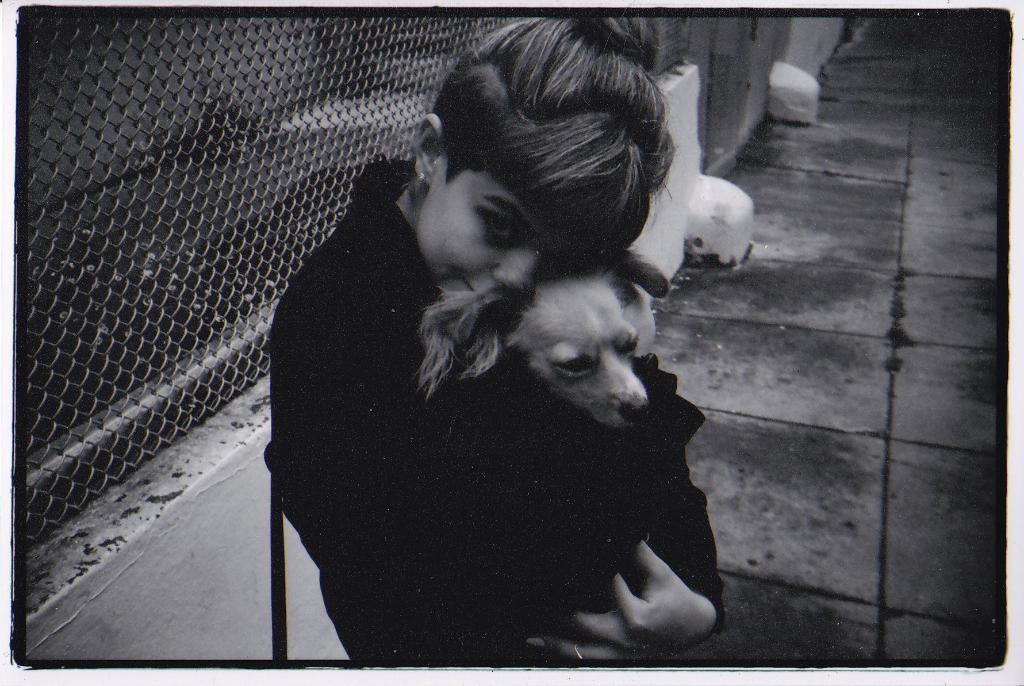Who is in the image? There is a girl in the image. What is the girl doing with her hands? The girl is holding a dog with her hands. What is the girl's facial expression? The girl is smiling. What can be seen in the background of the image? There is a path, a fencing net, walls, and some objects in the background of the image. What type of animal is the girl using to hook the objects in the image? There is no animal present in the image that could be used for hooking objects. Additionally, the girl is not using any animal to interact with the objects in the image. 